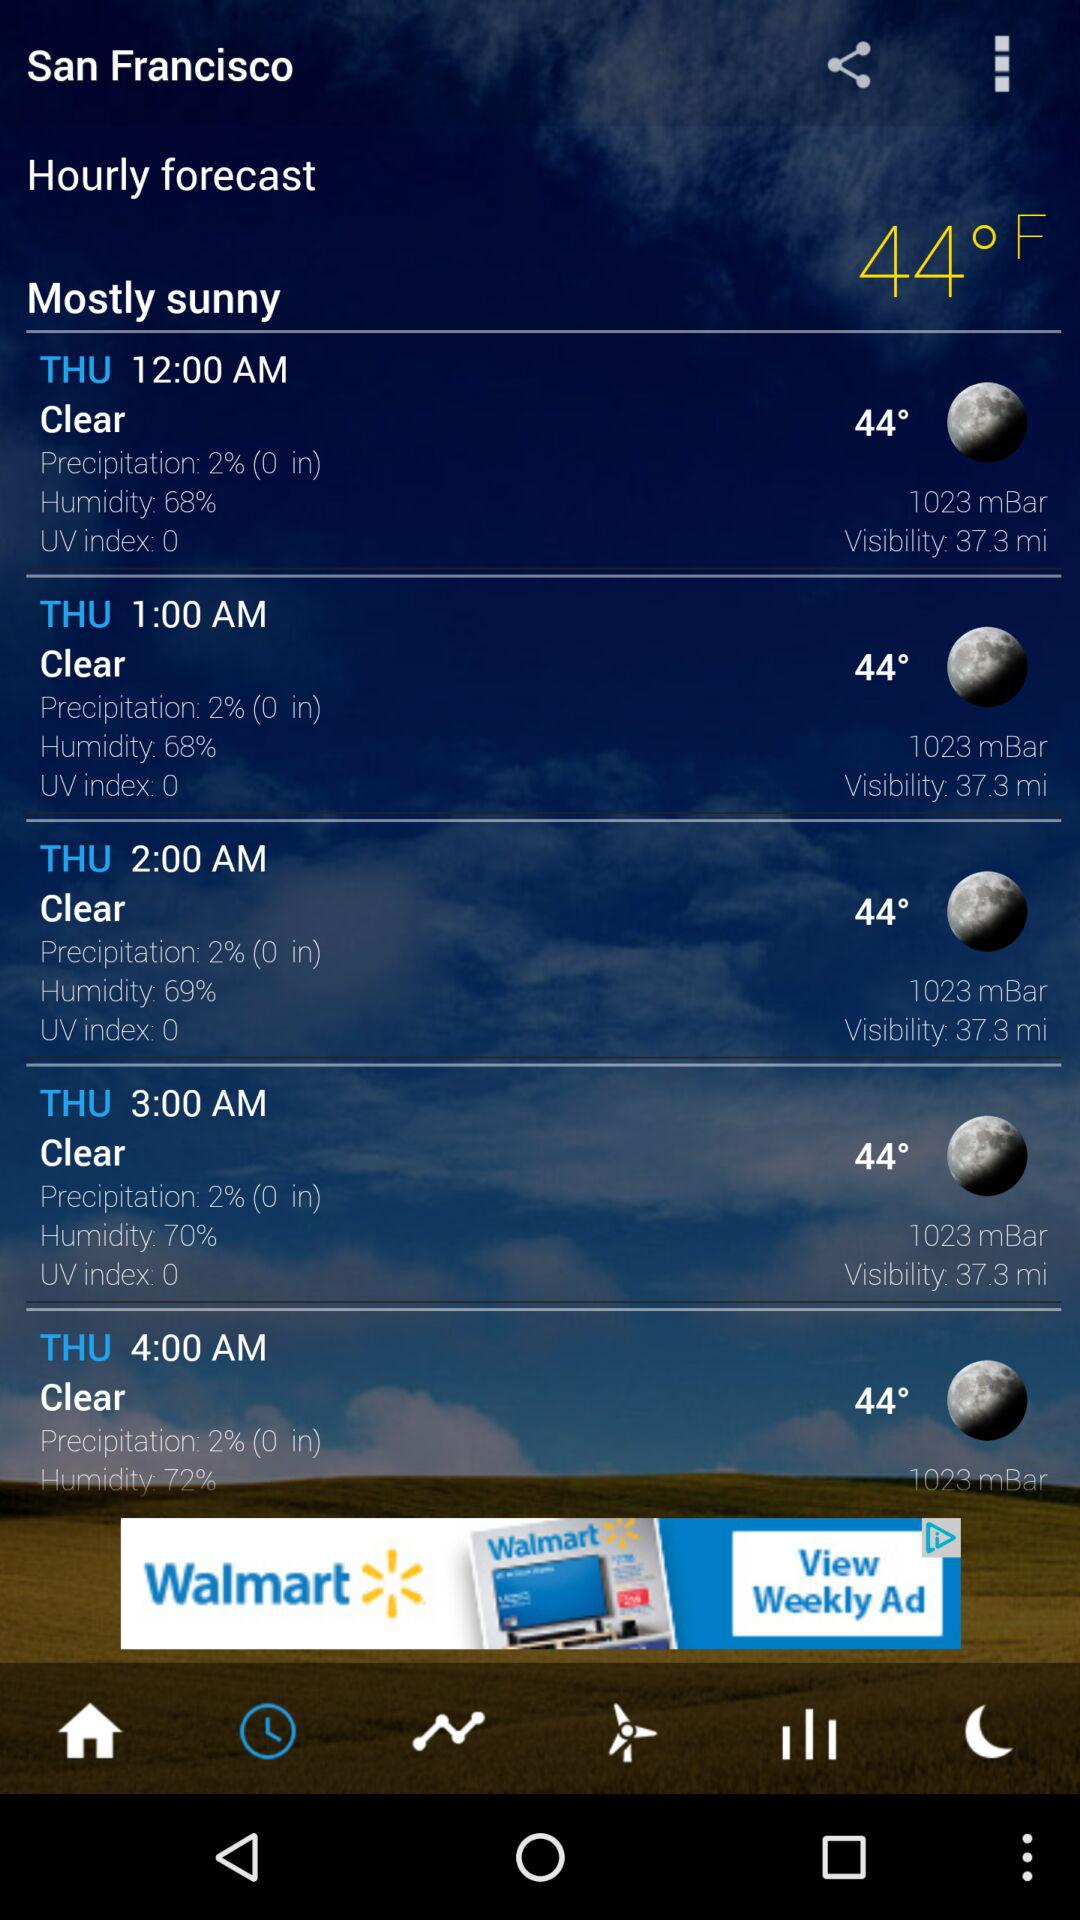What is the humidity at 3:00 a.m.? The humidity is 70%. 